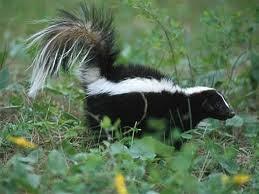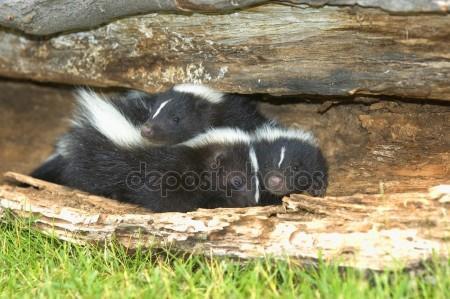The first image is the image on the left, the second image is the image on the right. Assess this claim about the two images: "The right image shows at least two skunks by the hollow of a fallen log.". Correct or not? Answer yes or no. Yes. The first image is the image on the left, the second image is the image on the right. Examine the images to the left and right. Is the description "Two skunks are on a piece of wood in one of the images." accurate? Answer yes or no. Yes. 